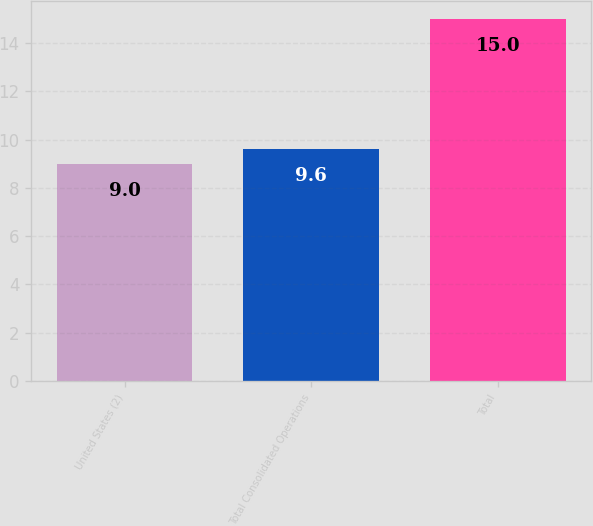<chart> <loc_0><loc_0><loc_500><loc_500><bar_chart><fcel>United States (2)<fcel>Total Consolidated Operations<fcel>Total<nl><fcel>9<fcel>9.6<fcel>15<nl></chart> 